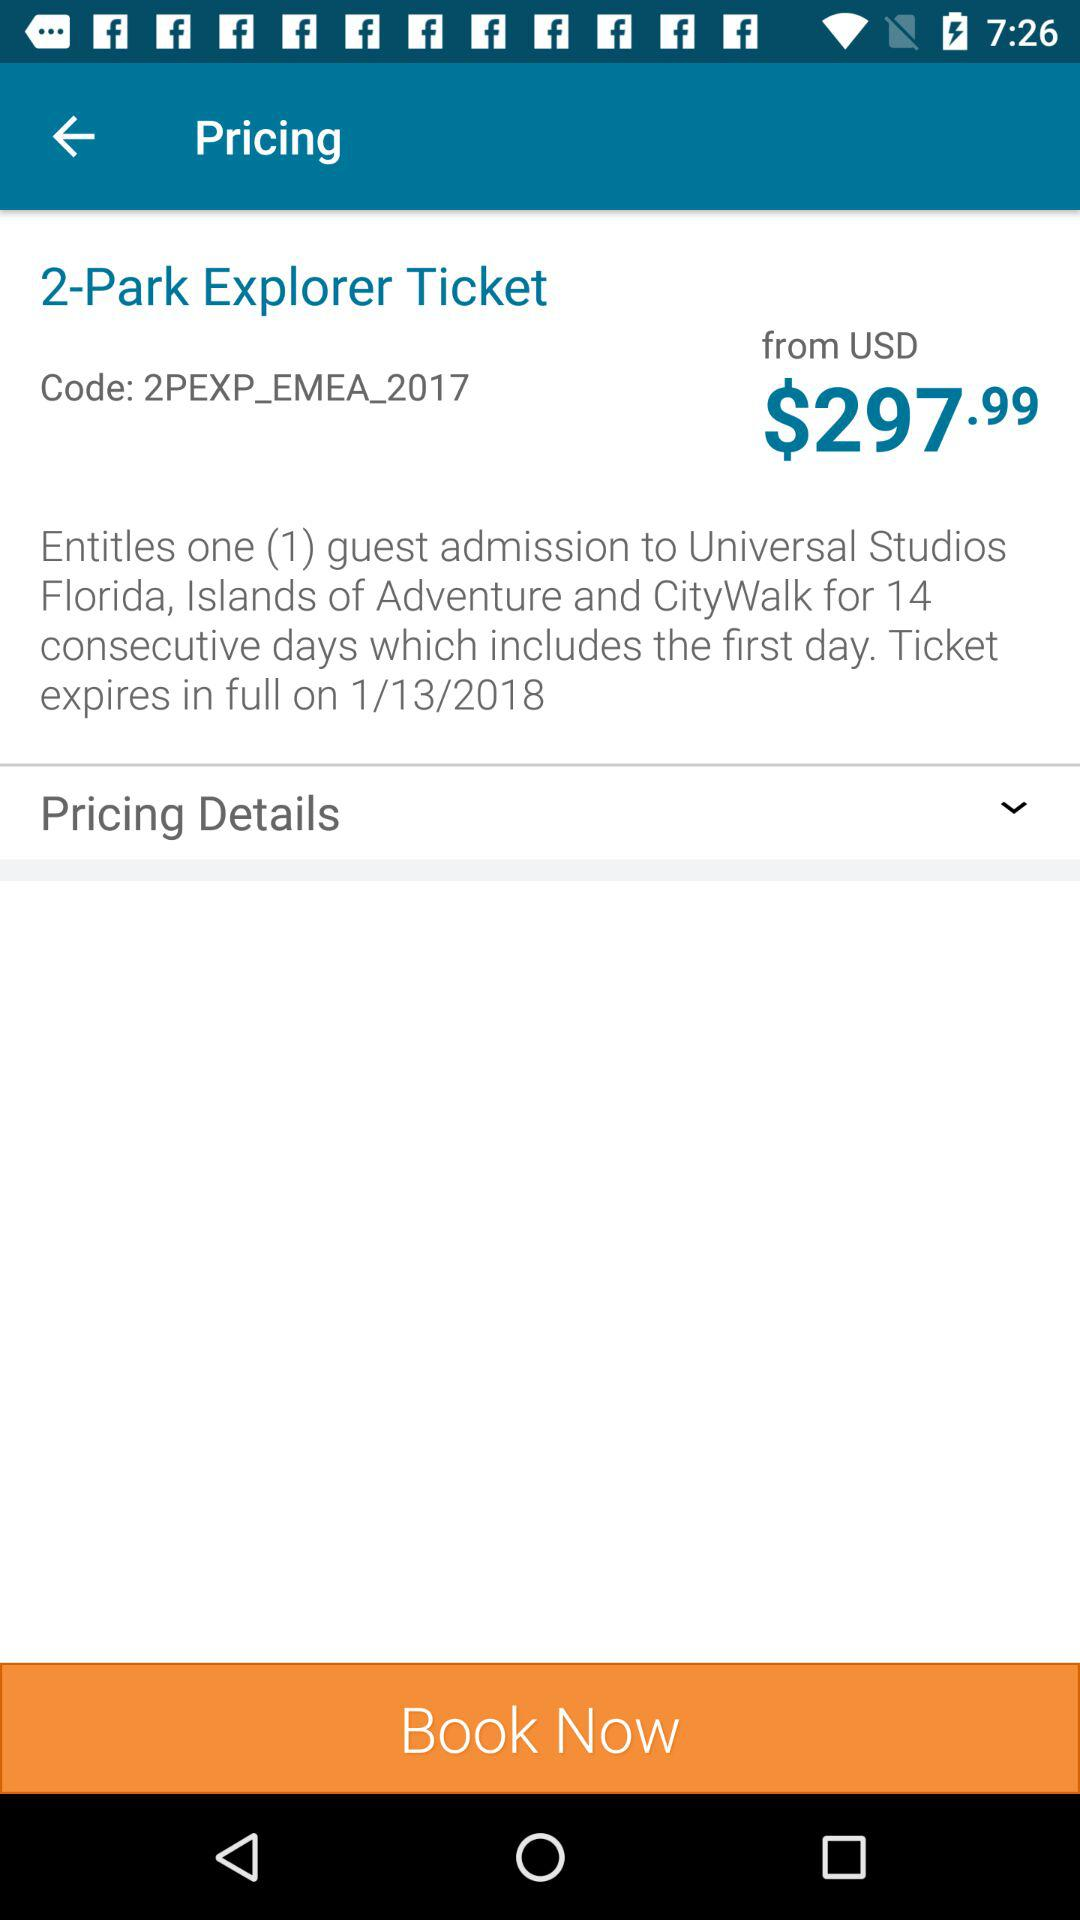What code is used for tickets? The code used for the ticket is "2PEXP_EMEA_2017". 